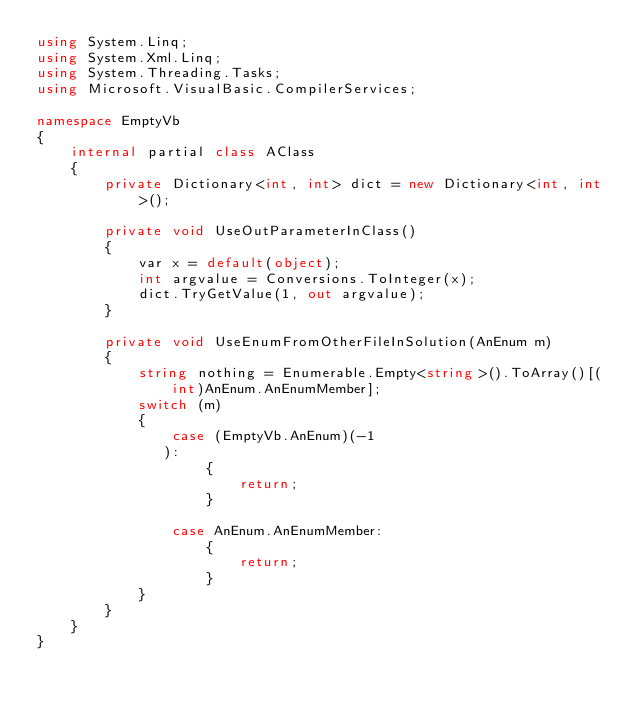Convert code to text. <code><loc_0><loc_0><loc_500><loc_500><_C#_>using System.Linq;
using System.Xml.Linq;
using System.Threading.Tasks;
using Microsoft.VisualBasic.CompilerServices;

namespace EmptyVb
{
    internal partial class AClass
    {
        private Dictionary<int, int> dict = new Dictionary<int, int>();

        private void UseOutParameterInClass()
        {
            var x = default(object);
            int argvalue = Conversions.ToInteger(x);
            dict.TryGetValue(1, out argvalue);
        }

        private void UseEnumFromOtherFileInSolution(AnEnum m)
        {
            string nothing = Enumerable.Empty<string>().ToArray()[(int)AnEnum.AnEnumMember];
            switch (m)
            {
                case (EmptyVb.AnEnum)(-1
               ):
                    {
                        return;
                    }

                case AnEnum.AnEnumMember:
                    {
                        return;
                    }
            }
        }
    }
}
</code> 